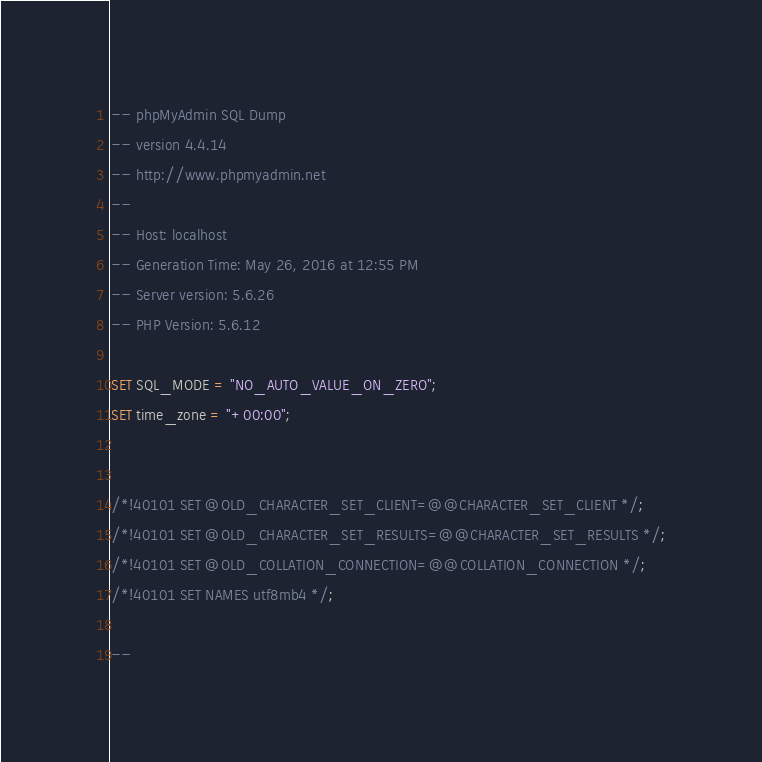Convert code to text. <code><loc_0><loc_0><loc_500><loc_500><_SQL_>-- phpMyAdmin SQL Dump
-- version 4.4.14
-- http://www.phpmyadmin.net
--
-- Host: localhost
-- Generation Time: May 26, 2016 at 12:55 PM
-- Server version: 5.6.26
-- PHP Version: 5.6.12

SET SQL_MODE = "NO_AUTO_VALUE_ON_ZERO";
SET time_zone = "+00:00";


/*!40101 SET @OLD_CHARACTER_SET_CLIENT=@@CHARACTER_SET_CLIENT */;
/*!40101 SET @OLD_CHARACTER_SET_RESULTS=@@CHARACTER_SET_RESULTS */;
/*!40101 SET @OLD_COLLATION_CONNECTION=@@COLLATION_CONNECTION */;
/*!40101 SET NAMES utf8mb4 */;

--</code> 